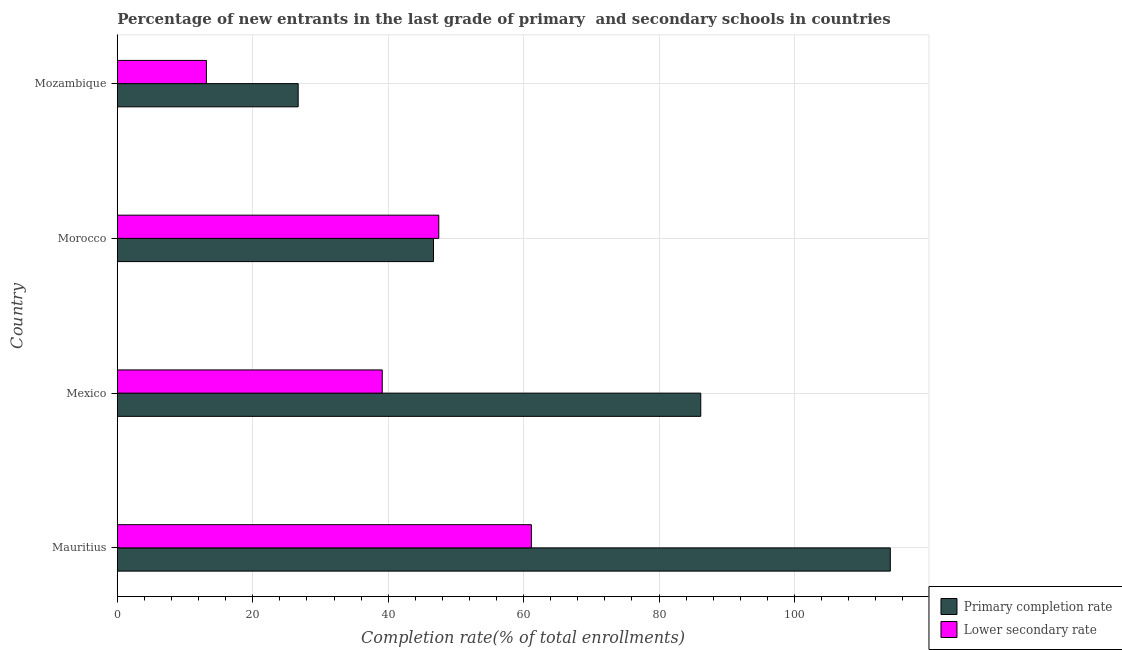Are the number of bars per tick equal to the number of legend labels?
Give a very brief answer. Yes. Are the number of bars on each tick of the Y-axis equal?
Offer a very short reply. Yes. How many bars are there on the 3rd tick from the top?
Offer a very short reply. 2. What is the label of the 3rd group of bars from the top?
Provide a short and direct response. Mexico. In how many cases, is the number of bars for a given country not equal to the number of legend labels?
Your response must be concise. 0. What is the completion rate in secondary schools in Mexico?
Your answer should be compact. 39.13. Across all countries, what is the maximum completion rate in primary schools?
Your answer should be very brief. 114.14. Across all countries, what is the minimum completion rate in secondary schools?
Provide a succinct answer. 13.16. In which country was the completion rate in primary schools maximum?
Your answer should be compact. Mauritius. In which country was the completion rate in secondary schools minimum?
Make the answer very short. Mozambique. What is the total completion rate in primary schools in the graph?
Give a very brief answer. 273.7. What is the difference between the completion rate in primary schools in Mauritius and that in Mexico?
Offer a terse response. 27.99. What is the difference between the completion rate in secondary schools in Morocco and the completion rate in primary schools in Mauritius?
Provide a succinct answer. -66.67. What is the average completion rate in secondary schools per country?
Make the answer very short. 40.23. What is the difference between the completion rate in primary schools and completion rate in secondary schools in Mauritius?
Ensure brevity in your answer.  53. In how many countries, is the completion rate in secondary schools greater than 20 %?
Give a very brief answer. 3. What is the ratio of the completion rate in primary schools in Mauritius to that in Mexico?
Provide a short and direct response. 1.32. Is the completion rate in primary schools in Mexico less than that in Morocco?
Offer a terse response. No. What is the difference between the highest and the second highest completion rate in secondary schools?
Make the answer very short. 13.67. What is the difference between the highest and the lowest completion rate in secondary schools?
Make the answer very short. 47.99. In how many countries, is the completion rate in primary schools greater than the average completion rate in primary schools taken over all countries?
Your response must be concise. 2. What does the 2nd bar from the top in Mauritius represents?
Your answer should be very brief. Primary completion rate. What does the 1st bar from the bottom in Mozambique represents?
Offer a terse response. Primary completion rate. How many bars are there?
Offer a terse response. 8. How many countries are there in the graph?
Provide a short and direct response. 4. What is the difference between two consecutive major ticks on the X-axis?
Provide a short and direct response. 20. Are the values on the major ticks of X-axis written in scientific E-notation?
Provide a short and direct response. No. Where does the legend appear in the graph?
Your answer should be compact. Bottom right. What is the title of the graph?
Provide a succinct answer. Percentage of new entrants in the last grade of primary  and secondary schools in countries. What is the label or title of the X-axis?
Keep it short and to the point. Completion rate(% of total enrollments). What is the label or title of the Y-axis?
Provide a short and direct response. Country. What is the Completion rate(% of total enrollments) of Primary completion rate in Mauritius?
Provide a short and direct response. 114.14. What is the Completion rate(% of total enrollments) of Lower secondary rate in Mauritius?
Keep it short and to the point. 61.15. What is the Completion rate(% of total enrollments) in Primary completion rate in Mexico?
Your answer should be very brief. 86.16. What is the Completion rate(% of total enrollments) in Lower secondary rate in Mexico?
Give a very brief answer. 39.13. What is the Completion rate(% of total enrollments) in Primary completion rate in Morocco?
Your answer should be compact. 46.69. What is the Completion rate(% of total enrollments) in Lower secondary rate in Morocco?
Provide a succinct answer. 47.47. What is the Completion rate(% of total enrollments) of Primary completion rate in Mozambique?
Give a very brief answer. 26.71. What is the Completion rate(% of total enrollments) of Lower secondary rate in Mozambique?
Give a very brief answer. 13.16. Across all countries, what is the maximum Completion rate(% of total enrollments) of Primary completion rate?
Offer a terse response. 114.14. Across all countries, what is the maximum Completion rate(% of total enrollments) of Lower secondary rate?
Your answer should be very brief. 61.15. Across all countries, what is the minimum Completion rate(% of total enrollments) in Primary completion rate?
Your answer should be very brief. 26.71. Across all countries, what is the minimum Completion rate(% of total enrollments) in Lower secondary rate?
Your response must be concise. 13.16. What is the total Completion rate(% of total enrollments) in Primary completion rate in the graph?
Your answer should be very brief. 273.7. What is the total Completion rate(% of total enrollments) in Lower secondary rate in the graph?
Provide a short and direct response. 160.91. What is the difference between the Completion rate(% of total enrollments) in Primary completion rate in Mauritius and that in Mexico?
Provide a short and direct response. 27.99. What is the difference between the Completion rate(% of total enrollments) in Lower secondary rate in Mauritius and that in Mexico?
Make the answer very short. 22.02. What is the difference between the Completion rate(% of total enrollments) of Primary completion rate in Mauritius and that in Morocco?
Offer a very short reply. 67.45. What is the difference between the Completion rate(% of total enrollments) of Lower secondary rate in Mauritius and that in Morocco?
Your response must be concise. 13.67. What is the difference between the Completion rate(% of total enrollments) in Primary completion rate in Mauritius and that in Mozambique?
Give a very brief answer. 87.43. What is the difference between the Completion rate(% of total enrollments) in Lower secondary rate in Mauritius and that in Mozambique?
Your answer should be compact. 47.99. What is the difference between the Completion rate(% of total enrollments) of Primary completion rate in Mexico and that in Morocco?
Your answer should be very brief. 39.47. What is the difference between the Completion rate(% of total enrollments) of Lower secondary rate in Mexico and that in Morocco?
Ensure brevity in your answer.  -8.35. What is the difference between the Completion rate(% of total enrollments) of Primary completion rate in Mexico and that in Mozambique?
Make the answer very short. 59.45. What is the difference between the Completion rate(% of total enrollments) of Lower secondary rate in Mexico and that in Mozambique?
Give a very brief answer. 25.96. What is the difference between the Completion rate(% of total enrollments) in Primary completion rate in Morocco and that in Mozambique?
Make the answer very short. 19.98. What is the difference between the Completion rate(% of total enrollments) of Lower secondary rate in Morocco and that in Mozambique?
Keep it short and to the point. 34.31. What is the difference between the Completion rate(% of total enrollments) of Primary completion rate in Mauritius and the Completion rate(% of total enrollments) of Lower secondary rate in Mexico?
Keep it short and to the point. 75.02. What is the difference between the Completion rate(% of total enrollments) of Primary completion rate in Mauritius and the Completion rate(% of total enrollments) of Lower secondary rate in Morocco?
Provide a short and direct response. 66.67. What is the difference between the Completion rate(% of total enrollments) of Primary completion rate in Mauritius and the Completion rate(% of total enrollments) of Lower secondary rate in Mozambique?
Ensure brevity in your answer.  100.98. What is the difference between the Completion rate(% of total enrollments) in Primary completion rate in Mexico and the Completion rate(% of total enrollments) in Lower secondary rate in Morocco?
Your response must be concise. 38.68. What is the difference between the Completion rate(% of total enrollments) of Primary completion rate in Mexico and the Completion rate(% of total enrollments) of Lower secondary rate in Mozambique?
Your answer should be compact. 72.99. What is the difference between the Completion rate(% of total enrollments) of Primary completion rate in Morocco and the Completion rate(% of total enrollments) of Lower secondary rate in Mozambique?
Your answer should be compact. 33.53. What is the average Completion rate(% of total enrollments) of Primary completion rate per country?
Your answer should be compact. 68.42. What is the average Completion rate(% of total enrollments) of Lower secondary rate per country?
Make the answer very short. 40.23. What is the difference between the Completion rate(% of total enrollments) of Primary completion rate and Completion rate(% of total enrollments) of Lower secondary rate in Mauritius?
Make the answer very short. 53. What is the difference between the Completion rate(% of total enrollments) of Primary completion rate and Completion rate(% of total enrollments) of Lower secondary rate in Mexico?
Offer a very short reply. 47.03. What is the difference between the Completion rate(% of total enrollments) in Primary completion rate and Completion rate(% of total enrollments) in Lower secondary rate in Morocco?
Your answer should be compact. -0.79. What is the difference between the Completion rate(% of total enrollments) of Primary completion rate and Completion rate(% of total enrollments) of Lower secondary rate in Mozambique?
Provide a succinct answer. 13.55. What is the ratio of the Completion rate(% of total enrollments) in Primary completion rate in Mauritius to that in Mexico?
Your response must be concise. 1.32. What is the ratio of the Completion rate(% of total enrollments) in Lower secondary rate in Mauritius to that in Mexico?
Ensure brevity in your answer.  1.56. What is the ratio of the Completion rate(% of total enrollments) in Primary completion rate in Mauritius to that in Morocco?
Offer a very short reply. 2.44. What is the ratio of the Completion rate(% of total enrollments) in Lower secondary rate in Mauritius to that in Morocco?
Provide a succinct answer. 1.29. What is the ratio of the Completion rate(% of total enrollments) of Primary completion rate in Mauritius to that in Mozambique?
Provide a short and direct response. 4.27. What is the ratio of the Completion rate(% of total enrollments) of Lower secondary rate in Mauritius to that in Mozambique?
Offer a very short reply. 4.65. What is the ratio of the Completion rate(% of total enrollments) in Primary completion rate in Mexico to that in Morocco?
Keep it short and to the point. 1.85. What is the ratio of the Completion rate(% of total enrollments) in Lower secondary rate in Mexico to that in Morocco?
Ensure brevity in your answer.  0.82. What is the ratio of the Completion rate(% of total enrollments) of Primary completion rate in Mexico to that in Mozambique?
Provide a short and direct response. 3.23. What is the ratio of the Completion rate(% of total enrollments) in Lower secondary rate in Mexico to that in Mozambique?
Make the answer very short. 2.97. What is the ratio of the Completion rate(% of total enrollments) in Primary completion rate in Morocco to that in Mozambique?
Provide a succinct answer. 1.75. What is the ratio of the Completion rate(% of total enrollments) of Lower secondary rate in Morocco to that in Mozambique?
Your answer should be compact. 3.61. What is the difference between the highest and the second highest Completion rate(% of total enrollments) in Primary completion rate?
Your answer should be compact. 27.99. What is the difference between the highest and the second highest Completion rate(% of total enrollments) in Lower secondary rate?
Ensure brevity in your answer.  13.67. What is the difference between the highest and the lowest Completion rate(% of total enrollments) of Primary completion rate?
Make the answer very short. 87.43. What is the difference between the highest and the lowest Completion rate(% of total enrollments) of Lower secondary rate?
Your answer should be very brief. 47.99. 